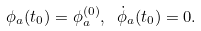<formula> <loc_0><loc_0><loc_500><loc_500>\phi _ { a } ( t _ { 0 } ) = \phi _ { a } ^ { ( 0 ) } , \ { \dot { \phi } } _ { a } ( t _ { 0 } ) = 0 .</formula> 